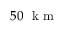<formula> <loc_0><loc_0><loc_500><loc_500>5 0 k m</formula> 